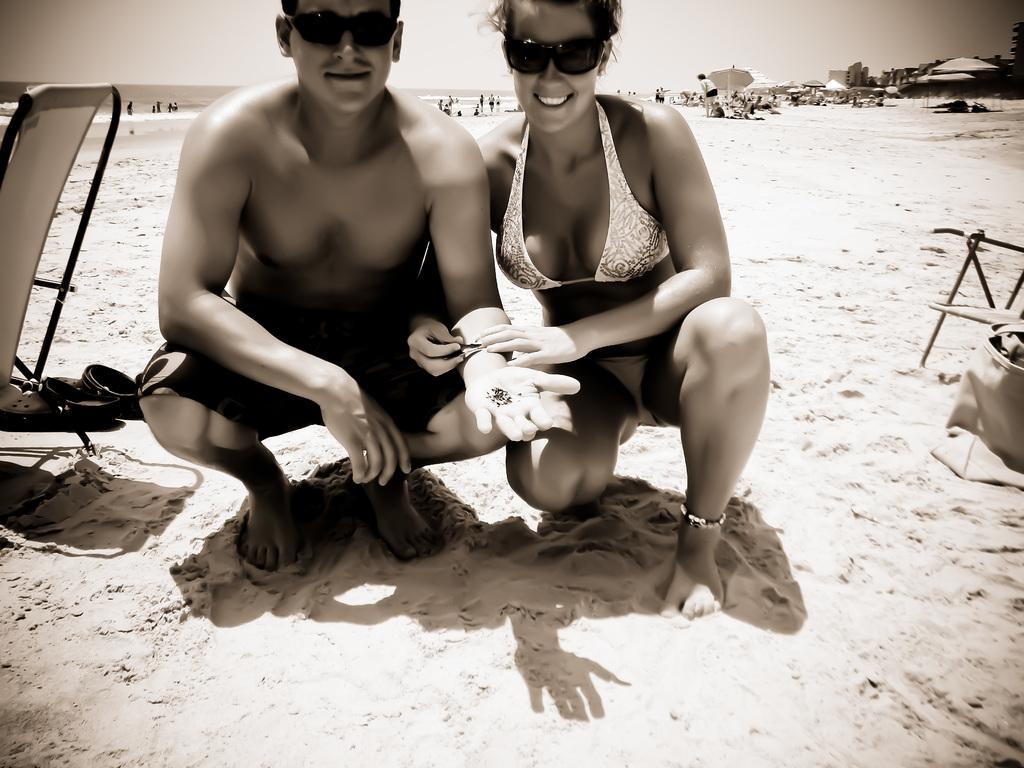What type of surface is visible in the image? There is sand in the image. What type of furniture is present in the image? There are chairs in the image. What objects are present to provide shade? There are umbrellas in the image. Can you describe the people in the image? There are people in the image. What can be seen in the distance in the image? There is water and buildings visible in the background of the image. What is visible at the top of the image? The sky is visible at the top of the image. What type of ear is visible in the image? There is no ear present in the image. What type of scale can be seen being used by the people in the image? There is no scale present in the image. 